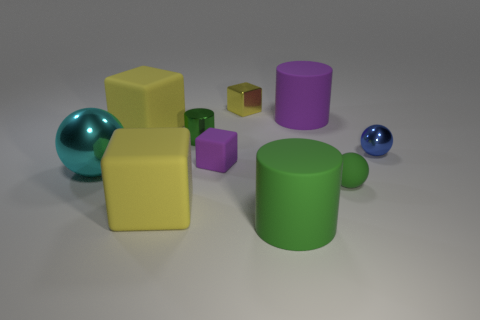Subtract all green balls. How many yellow blocks are left? 3 Subtract all cubes. How many objects are left? 6 Subtract 0 gray blocks. How many objects are left? 10 Subtract all yellow shiny blocks. Subtract all shiny cubes. How many objects are left? 8 Add 9 tiny yellow blocks. How many tiny yellow blocks are left? 10 Add 10 tiny brown rubber blocks. How many tiny brown rubber blocks exist? 10 